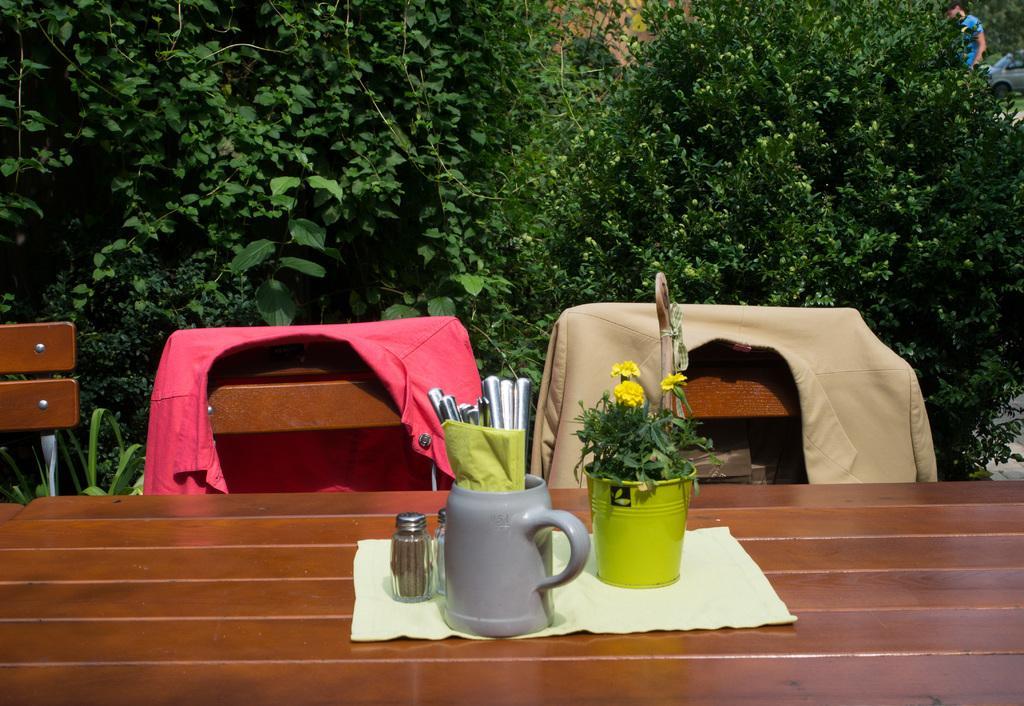Could you give a brief overview of what you see in this image? In this image I can see a table and the chairs. On the table there is a cup,spoon,shaker and the flower vase. On the chair there are clothes. In the background there are trees. 